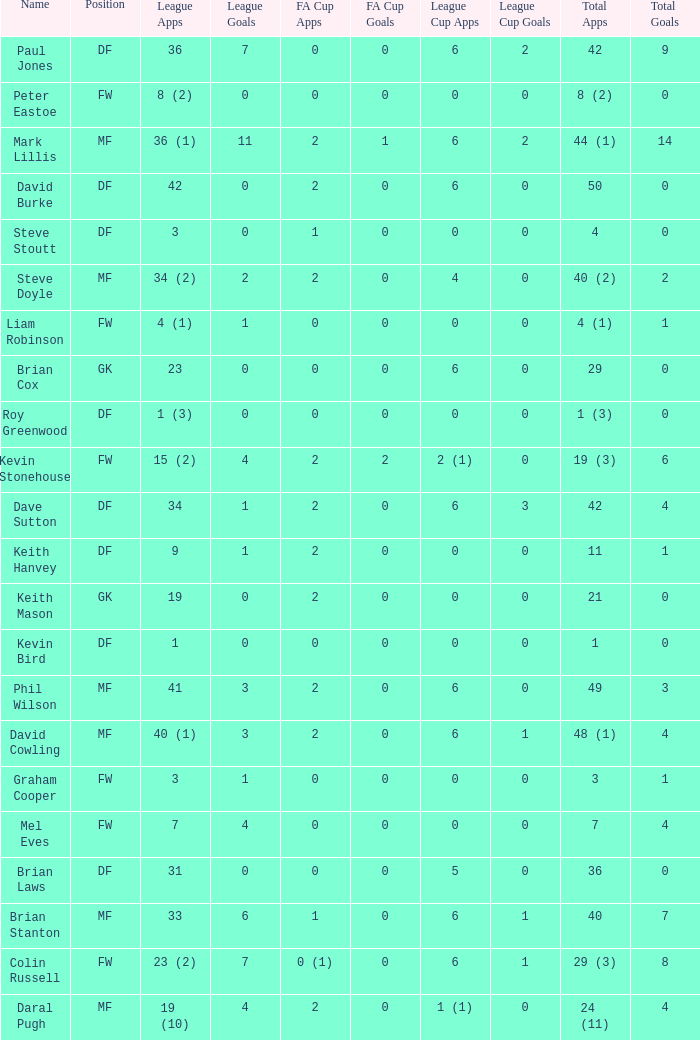What is the most total goals for a player having 0 FA Cup goals and 41 League appearances? 3.0. 